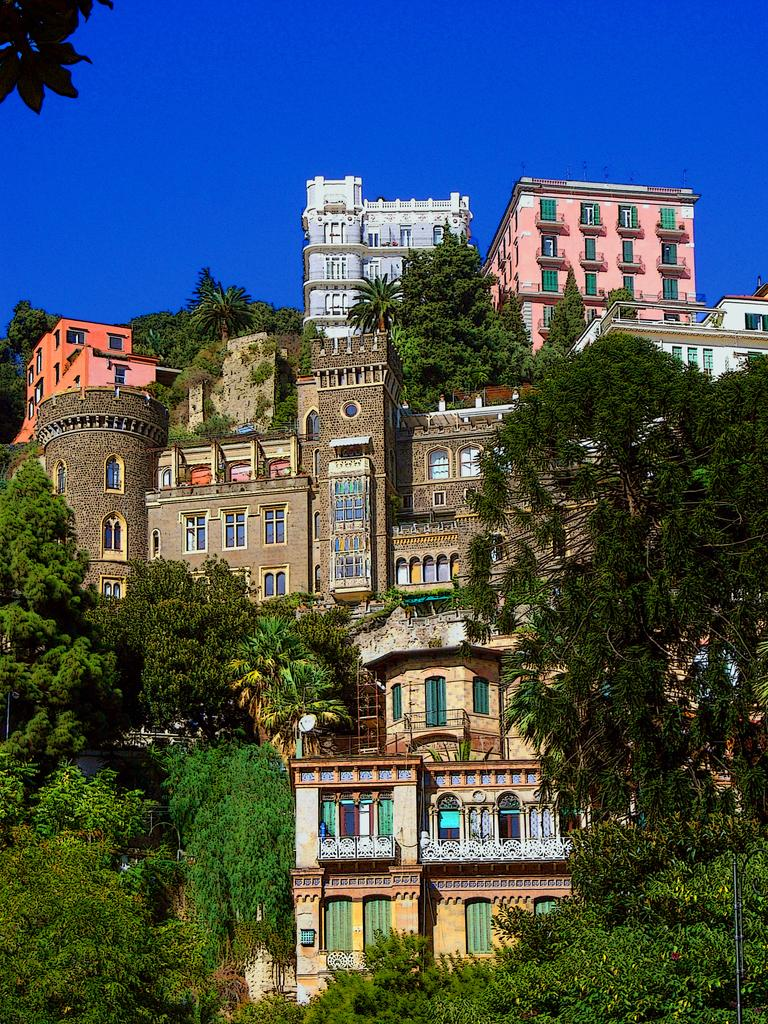What structures are located in the foreground area of the image? There are buildings in the foreground area of the image. What type of vegetation is present in the foreground area of the image? There are trees in the foreground area of the image. What is visible in the background of the image? The sky is visible in the background of the image. What flavor of ice cream are the boys enjoying in the image? There is no ice cream or boys present in the image. What channel is the image being broadcasted on? The image is not a video or being broadcasted on any channel; it is a static image. 